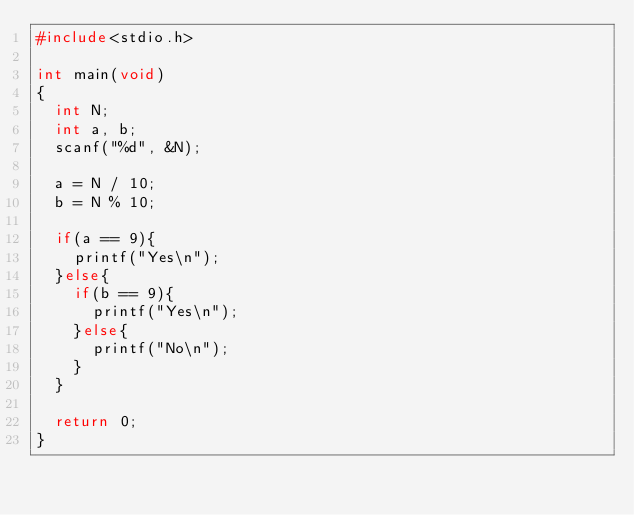<code> <loc_0><loc_0><loc_500><loc_500><_C_>#include<stdio.h>

int main(void)
{
  int N;
  int a, b;
  scanf("%d", &N);
  
  a = N / 10;
  b = N % 10;
  
  if(a == 9){
    printf("Yes\n");
  }else{
    if(b == 9){
      printf("Yes\n");
    }else{
      printf("No\n");
    }
  }
  
  return 0;
}</code> 